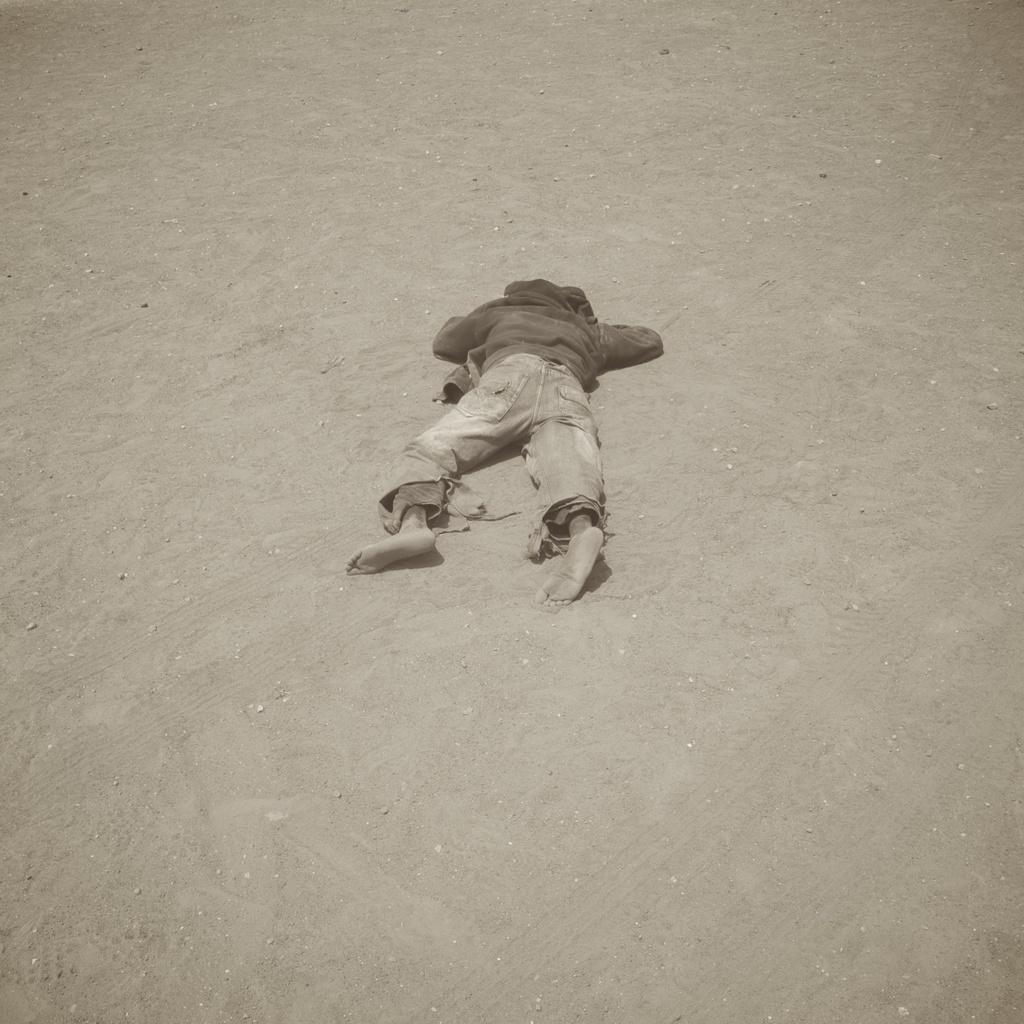In one or two sentences, can you explain what this image depicts? In the picture,there is a person laying on the sand ground. 